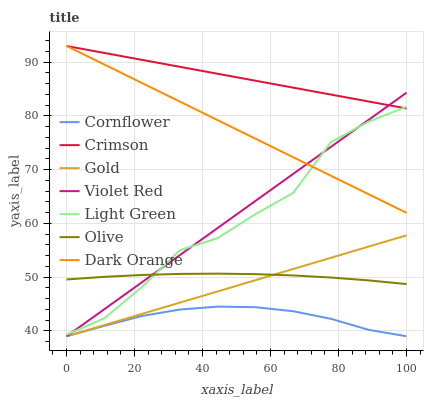Does Cornflower have the minimum area under the curve?
Answer yes or no. Yes. Does Crimson have the maximum area under the curve?
Answer yes or no. Yes. Does Violet Red have the minimum area under the curve?
Answer yes or no. No. Does Violet Red have the maximum area under the curve?
Answer yes or no. No. Is Gold the smoothest?
Answer yes or no. Yes. Is Light Green the roughest?
Answer yes or no. Yes. Is Violet Red the smoothest?
Answer yes or no. No. Is Violet Red the roughest?
Answer yes or no. No. Does Cornflower have the lowest value?
Answer yes or no. Yes. Does Dark Orange have the lowest value?
Answer yes or no. No. Does Crimson have the highest value?
Answer yes or no. Yes. Does Violet Red have the highest value?
Answer yes or no. No. Is Gold less than Crimson?
Answer yes or no. Yes. Is Dark Orange greater than Cornflower?
Answer yes or no. Yes. Does Dark Orange intersect Violet Red?
Answer yes or no. Yes. Is Dark Orange less than Violet Red?
Answer yes or no. No. Is Dark Orange greater than Violet Red?
Answer yes or no. No. Does Gold intersect Crimson?
Answer yes or no. No. 